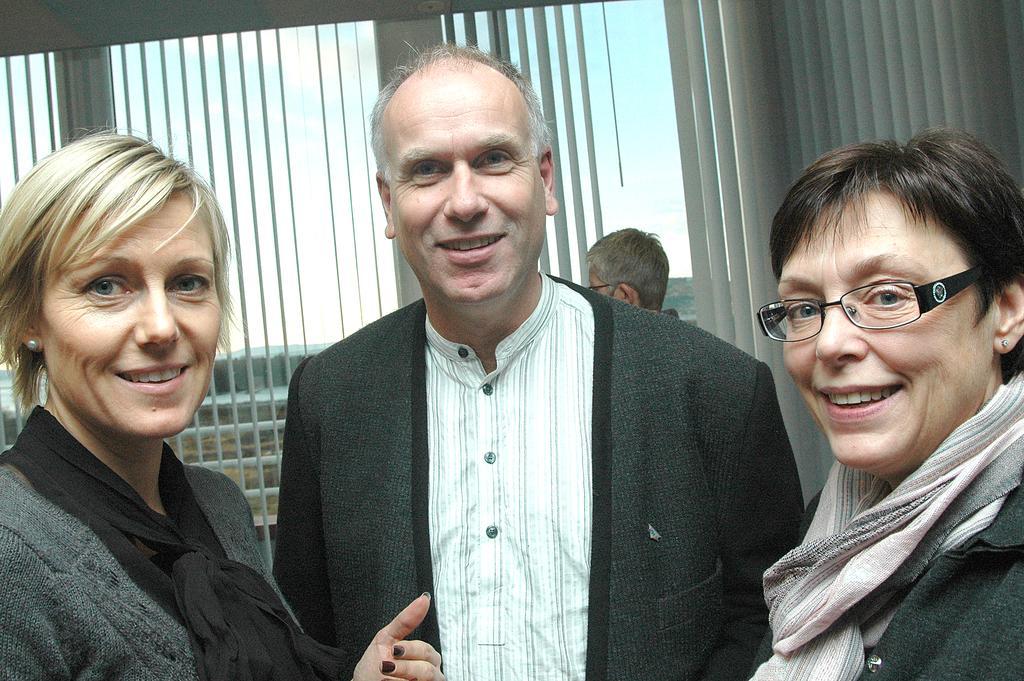Can you describe this image briefly? In this picture we can see 3 people standing here. They are looking and smiling at someone. 